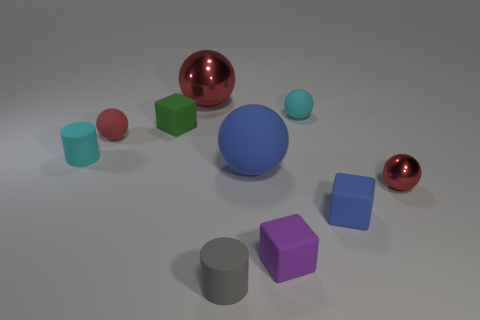Is the number of big red balls that are in front of the cyan rubber cylinder less than the number of small green rubber cylinders?
Your answer should be very brief. No. How many tiny cylinders have the same color as the large matte ball?
Your response must be concise. 0. Are there fewer tiny blue cubes than gray shiny blocks?
Your answer should be very brief. No. Is the tiny green object made of the same material as the large red ball?
Make the answer very short. No. How many other objects are there of the same size as the gray thing?
Offer a terse response. 7. What is the color of the tiny matte cylinder to the right of the tiny matte sphere that is in front of the small cyan matte sphere?
Make the answer very short. Gray. What number of other objects are there of the same shape as the small metal thing?
Offer a terse response. 4. Is there a small purple cube that has the same material as the purple object?
Offer a terse response. No. There is a red object that is the same size as the red rubber ball; what is its material?
Give a very brief answer. Metal. What color is the cylinder to the right of the big shiny ball behind the small cube that is on the left side of the big rubber sphere?
Your response must be concise. Gray. 